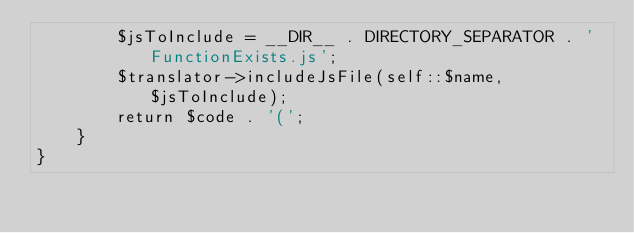<code> <loc_0><loc_0><loc_500><loc_500><_PHP_>        $jsToInclude = __DIR__ . DIRECTORY_SEPARATOR . 'FunctionExists.js';
        $translator->includeJsFile(self::$name, $jsToInclude);
        return $code . '(';
    }
}
</code> 